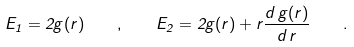Convert formula to latex. <formula><loc_0><loc_0><loc_500><loc_500>E _ { 1 } = 2 g ( r ) \quad , \quad E _ { 2 } = 2 g ( r ) + r \frac { d \, g ( r ) } { d \, r } \quad .</formula> 